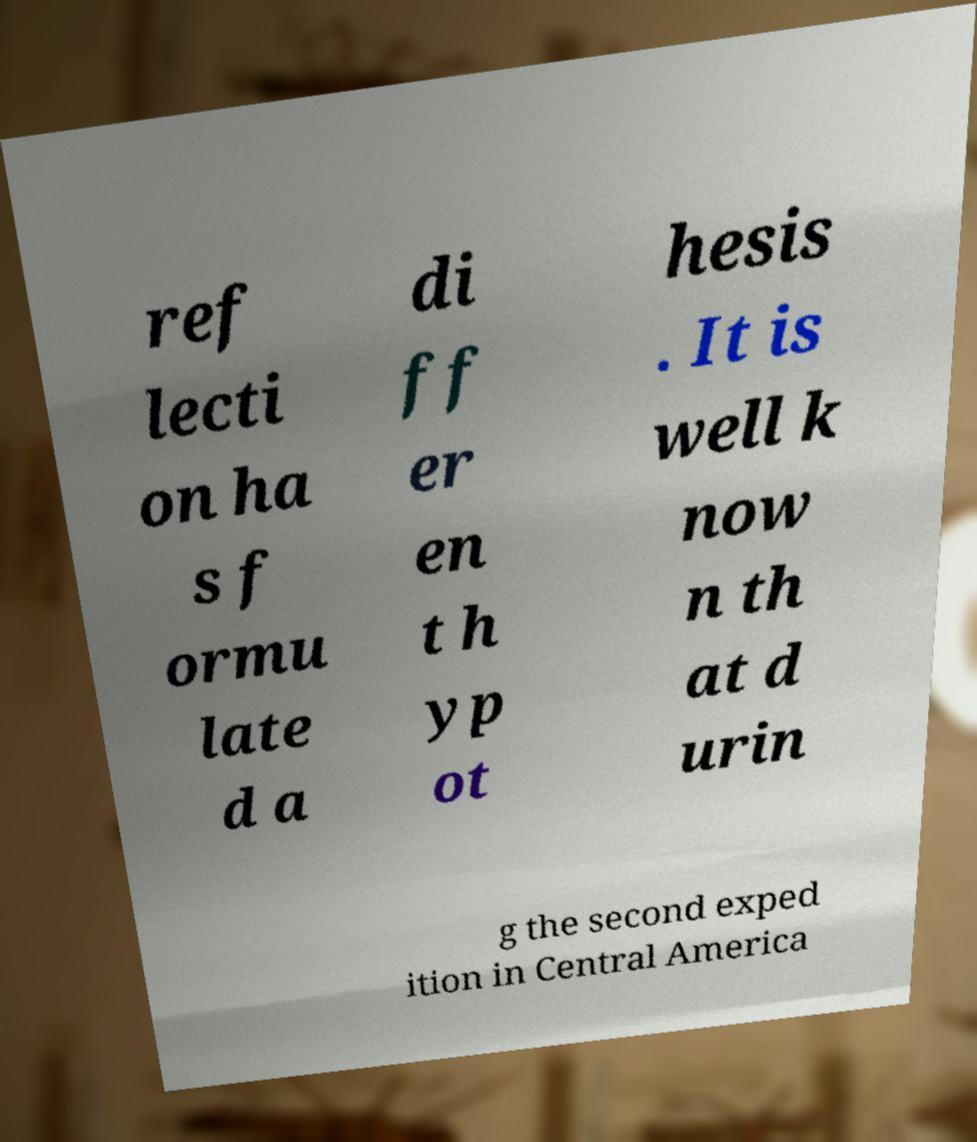Could you extract and type out the text from this image? ref lecti on ha s f ormu late d a di ff er en t h yp ot hesis . It is well k now n th at d urin g the second exped ition in Central America 